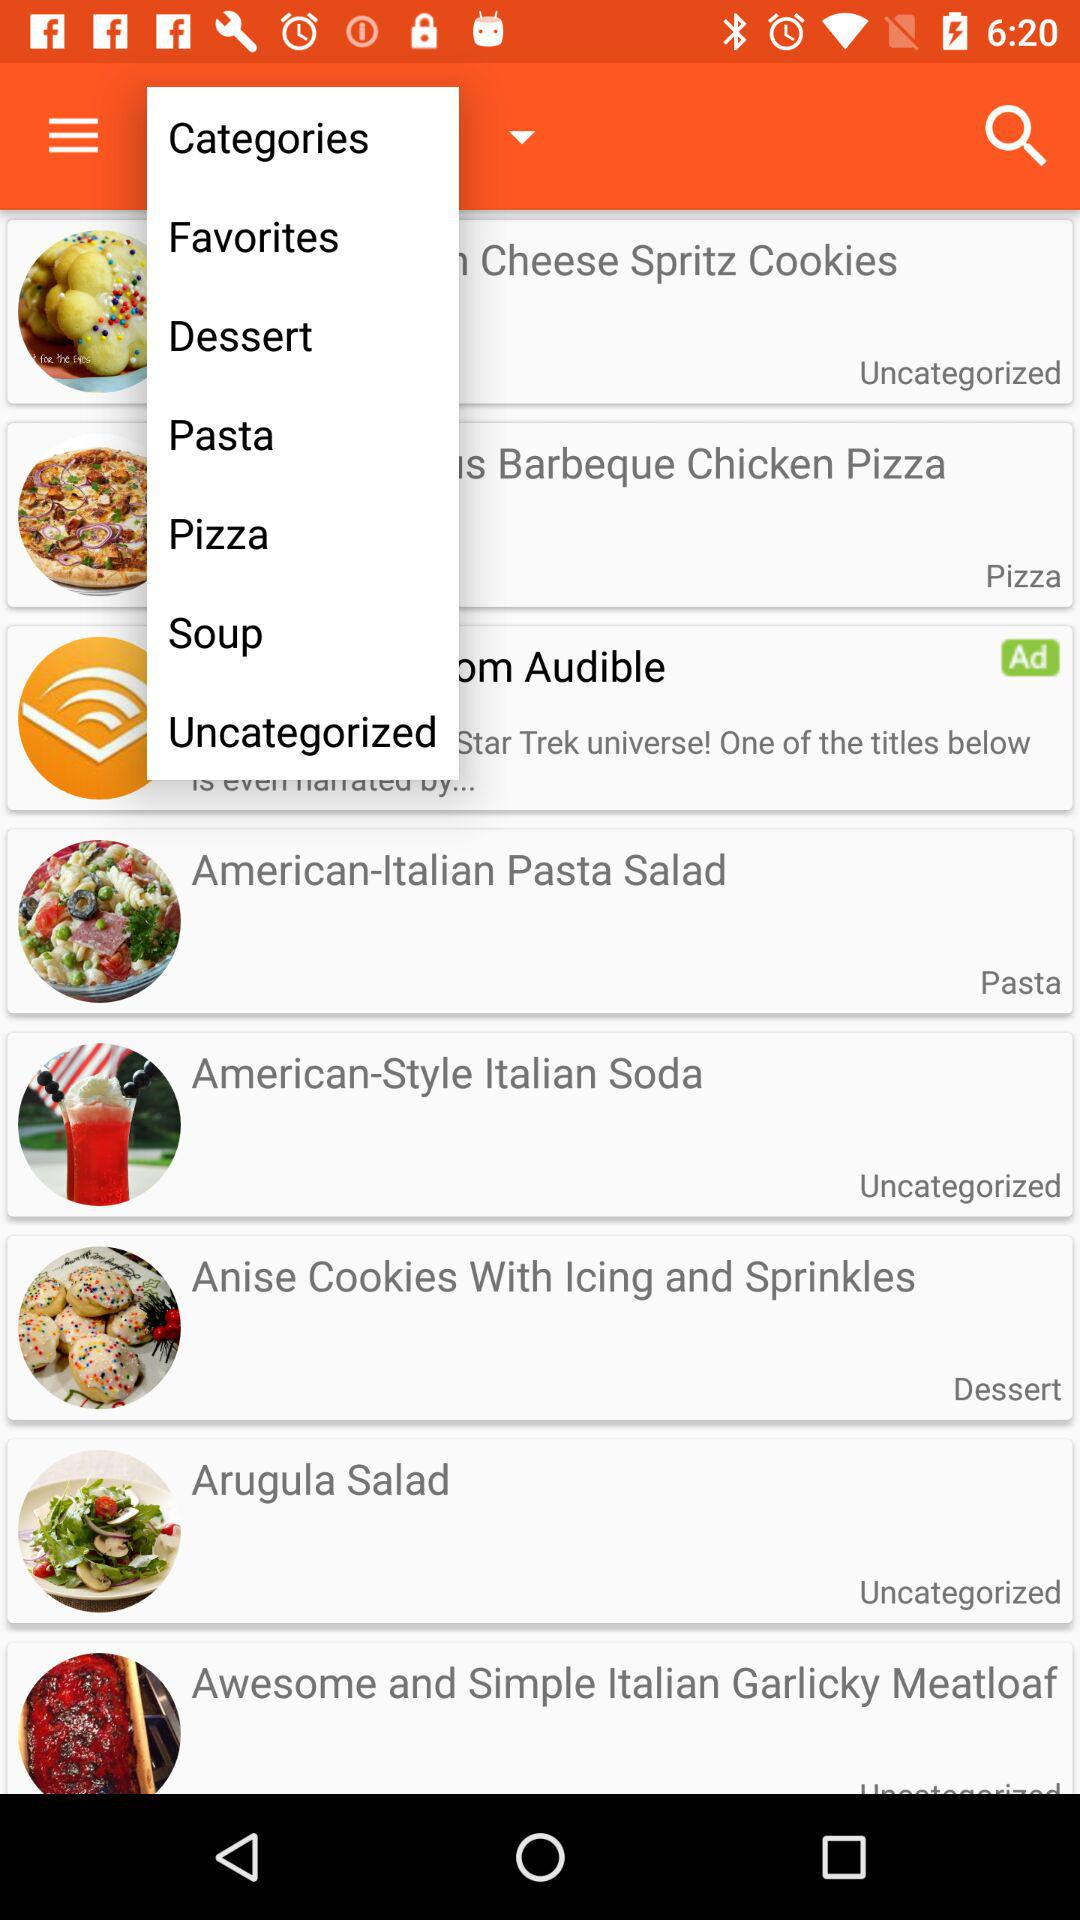Which dish comes under the dessert category? The dish which comes under the dessert category is "Anise Cookies With Icing and Sprinkles". 